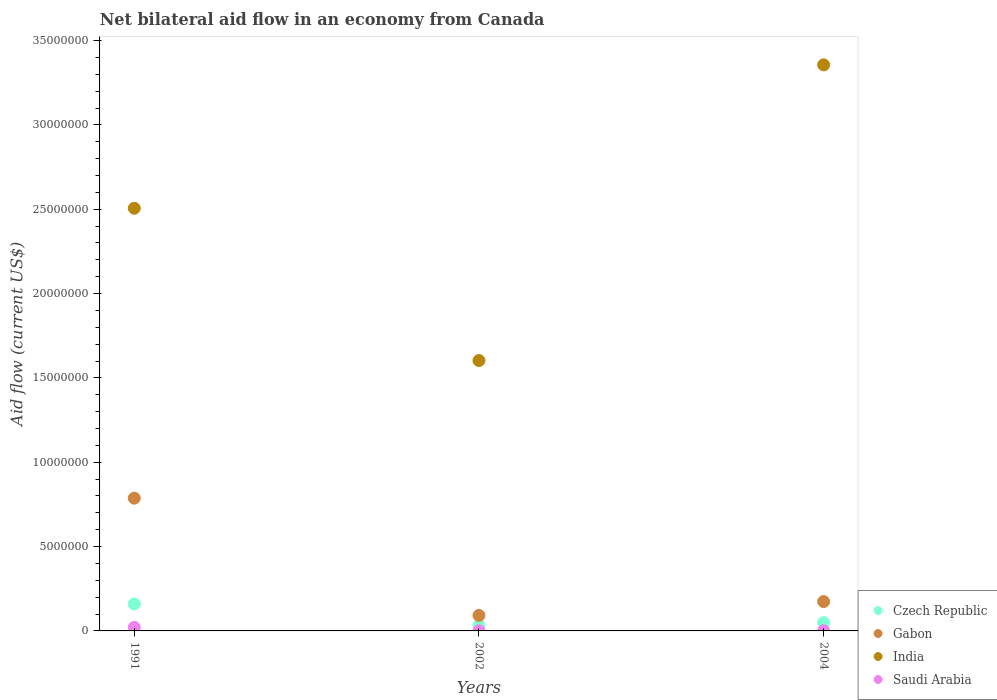Across all years, what is the maximum net bilateral aid flow in Gabon?
Make the answer very short. 7.87e+06. Across all years, what is the minimum net bilateral aid flow in Gabon?
Make the answer very short. 9.20e+05. In which year was the net bilateral aid flow in Czech Republic maximum?
Your answer should be very brief. 1991. In which year was the net bilateral aid flow in India minimum?
Offer a terse response. 2002. What is the difference between the net bilateral aid flow in Saudi Arabia in 2004 and the net bilateral aid flow in Czech Republic in 2002?
Provide a succinct answer. -3.20e+05. What is the average net bilateral aid flow in Czech Republic per year?
Your response must be concise. 8.07e+05. In the year 2004, what is the difference between the net bilateral aid flow in Saudi Arabia and net bilateral aid flow in Gabon?
Offer a terse response. -1.73e+06. In how many years, is the net bilateral aid flow in India greater than 7000000 US$?
Your answer should be compact. 3. What is the ratio of the net bilateral aid flow in India in 1991 to that in 2002?
Offer a very short reply. 1.56. Is the difference between the net bilateral aid flow in Saudi Arabia in 2002 and 2004 greater than the difference between the net bilateral aid flow in Gabon in 2002 and 2004?
Offer a very short reply. Yes. What is the difference between the highest and the second highest net bilateral aid flow in Gabon?
Offer a terse response. 6.13e+06. What is the difference between the highest and the lowest net bilateral aid flow in Czech Republic?
Make the answer very short. 1.27e+06. Is the sum of the net bilateral aid flow in Saudi Arabia in 2002 and 2004 greater than the maximum net bilateral aid flow in Gabon across all years?
Your response must be concise. No. Is it the case that in every year, the sum of the net bilateral aid flow in Czech Republic and net bilateral aid flow in Saudi Arabia  is greater than the sum of net bilateral aid flow in India and net bilateral aid flow in Gabon?
Your answer should be very brief. No. Is it the case that in every year, the sum of the net bilateral aid flow in India and net bilateral aid flow in Gabon  is greater than the net bilateral aid flow in Saudi Arabia?
Provide a short and direct response. Yes. How many dotlines are there?
Your answer should be compact. 4. Does the graph contain grids?
Provide a succinct answer. No. Where does the legend appear in the graph?
Ensure brevity in your answer.  Bottom right. How many legend labels are there?
Ensure brevity in your answer.  4. What is the title of the graph?
Keep it short and to the point. Net bilateral aid flow in an economy from Canada. What is the label or title of the X-axis?
Your response must be concise. Years. What is the label or title of the Y-axis?
Provide a succinct answer. Aid flow (current US$). What is the Aid flow (current US$) in Czech Republic in 1991?
Keep it short and to the point. 1.60e+06. What is the Aid flow (current US$) of Gabon in 1991?
Your answer should be compact. 7.87e+06. What is the Aid flow (current US$) of India in 1991?
Your response must be concise. 2.51e+07. What is the Aid flow (current US$) of Gabon in 2002?
Keep it short and to the point. 9.20e+05. What is the Aid flow (current US$) of India in 2002?
Provide a succinct answer. 1.60e+07. What is the Aid flow (current US$) of Gabon in 2004?
Offer a terse response. 1.74e+06. What is the Aid flow (current US$) in India in 2004?
Provide a succinct answer. 3.36e+07. What is the Aid flow (current US$) of Saudi Arabia in 2004?
Your answer should be compact. 10000. Across all years, what is the maximum Aid flow (current US$) of Czech Republic?
Your answer should be very brief. 1.60e+06. Across all years, what is the maximum Aid flow (current US$) in Gabon?
Keep it short and to the point. 7.87e+06. Across all years, what is the maximum Aid flow (current US$) in India?
Provide a short and direct response. 3.36e+07. Across all years, what is the minimum Aid flow (current US$) in Czech Republic?
Offer a terse response. 3.30e+05. Across all years, what is the minimum Aid flow (current US$) in Gabon?
Offer a very short reply. 9.20e+05. Across all years, what is the minimum Aid flow (current US$) of India?
Ensure brevity in your answer.  1.60e+07. What is the total Aid flow (current US$) in Czech Republic in the graph?
Offer a terse response. 2.42e+06. What is the total Aid flow (current US$) in Gabon in the graph?
Ensure brevity in your answer.  1.05e+07. What is the total Aid flow (current US$) of India in the graph?
Your response must be concise. 7.46e+07. What is the difference between the Aid flow (current US$) in Czech Republic in 1991 and that in 2002?
Your answer should be compact. 1.27e+06. What is the difference between the Aid flow (current US$) in Gabon in 1991 and that in 2002?
Keep it short and to the point. 6.95e+06. What is the difference between the Aid flow (current US$) in India in 1991 and that in 2002?
Give a very brief answer. 9.03e+06. What is the difference between the Aid flow (current US$) in Saudi Arabia in 1991 and that in 2002?
Your answer should be very brief. 2.00e+05. What is the difference between the Aid flow (current US$) in Czech Republic in 1991 and that in 2004?
Your response must be concise. 1.11e+06. What is the difference between the Aid flow (current US$) of Gabon in 1991 and that in 2004?
Your answer should be compact. 6.13e+06. What is the difference between the Aid flow (current US$) in India in 1991 and that in 2004?
Your answer should be very brief. -8.50e+06. What is the difference between the Aid flow (current US$) in Saudi Arabia in 1991 and that in 2004?
Make the answer very short. 2.00e+05. What is the difference between the Aid flow (current US$) in Czech Republic in 2002 and that in 2004?
Make the answer very short. -1.60e+05. What is the difference between the Aid flow (current US$) of Gabon in 2002 and that in 2004?
Your answer should be compact. -8.20e+05. What is the difference between the Aid flow (current US$) in India in 2002 and that in 2004?
Ensure brevity in your answer.  -1.75e+07. What is the difference between the Aid flow (current US$) of Czech Republic in 1991 and the Aid flow (current US$) of Gabon in 2002?
Ensure brevity in your answer.  6.80e+05. What is the difference between the Aid flow (current US$) of Czech Republic in 1991 and the Aid flow (current US$) of India in 2002?
Your response must be concise. -1.44e+07. What is the difference between the Aid flow (current US$) in Czech Republic in 1991 and the Aid flow (current US$) in Saudi Arabia in 2002?
Ensure brevity in your answer.  1.59e+06. What is the difference between the Aid flow (current US$) in Gabon in 1991 and the Aid flow (current US$) in India in 2002?
Keep it short and to the point. -8.16e+06. What is the difference between the Aid flow (current US$) in Gabon in 1991 and the Aid flow (current US$) in Saudi Arabia in 2002?
Provide a short and direct response. 7.86e+06. What is the difference between the Aid flow (current US$) in India in 1991 and the Aid flow (current US$) in Saudi Arabia in 2002?
Provide a succinct answer. 2.50e+07. What is the difference between the Aid flow (current US$) in Czech Republic in 1991 and the Aid flow (current US$) in India in 2004?
Offer a terse response. -3.20e+07. What is the difference between the Aid flow (current US$) in Czech Republic in 1991 and the Aid flow (current US$) in Saudi Arabia in 2004?
Your answer should be compact. 1.59e+06. What is the difference between the Aid flow (current US$) of Gabon in 1991 and the Aid flow (current US$) of India in 2004?
Offer a very short reply. -2.57e+07. What is the difference between the Aid flow (current US$) of Gabon in 1991 and the Aid flow (current US$) of Saudi Arabia in 2004?
Your response must be concise. 7.86e+06. What is the difference between the Aid flow (current US$) in India in 1991 and the Aid flow (current US$) in Saudi Arabia in 2004?
Your response must be concise. 2.50e+07. What is the difference between the Aid flow (current US$) of Czech Republic in 2002 and the Aid flow (current US$) of Gabon in 2004?
Keep it short and to the point. -1.41e+06. What is the difference between the Aid flow (current US$) in Czech Republic in 2002 and the Aid flow (current US$) in India in 2004?
Provide a succinct answer. -3.32e+07. What is the difference between the Aid flow (current US$) in Czech Republic in 2002 and the Aid flow (current US$) in Saudi Arabia in 2004?
Offer a terse response. 3.20e+05. What is the difference between the Aid flow (current US$) in Gabon in 2002 and the Aid flow (current US$) in India in 2004?
Your answer should be compact. -3.26e+07. What is the difference between the Aid flow (current US$) in Gabon in 2002 and the Aid flow (current US$) in Saudi Arabia in 2004?
Provide a succinct answer. 9.10e+05. What is the difference between the Aid flow (current US$) in India in 2002 and the Aid flow (current US$) in Saudi Arabia in 2004?
Make the answer very short. 1.60e+07. What is the average Aid flow (current US$) in Czech Republic per year?
Ensure brevity in your answer.  8.07e+05. What is the average Aid flow (current US$) in Gabon per year?
Your response must be concise. 3.51e+06. What is the average Aid flow (current US$) in India per year?
Provide a short and direct response. 2.49e+07. What is the average Aid flow (current US$) of Saudi Arabia per year?
Ensure brevity in your answer.  7.67e+04. In the year 1991, what is the difference between the Aid flow (current US$) in Czech Republic and Aid flow (current US$) in Gabon?
Give a very brief answer. -6.27e+06. In the year 1991, what is the difference between the Aid flow (current US$) of Czech Republic and Aid flow (current US$) of India?
Give a very brief answer. -2.35e+07. In the year 1991, what is the difference between the Aid flow (current US$) of Czech Republic and Aid flow (current US$) of Saudi Arabia?
Offer a terse response. 1.39e+06. In the year 1991, what is the difference between the Aid flow (current US$) in Gabon and Aid flow (current US$) in India?
Provide a short and direct response. -1.72e+07. In the year 1991, what is the difference between the Aid flow (current US$) in Gabon and Aid flow (current US$) in Saudi Arabia?
Your response must be concise. 7.66e+06. In the year 1991, what is the difference between the Aid flow (current US$) in India and Aid flow (current US$) in Saudi Arabia?
Ensure brevity in your answer.  2.48e+07. In the year 2002, what is the difference between the Aid flow (current US$) in Czech Republic and Aid flow (current US$) in Gabon?
Ensure brevity in your answer.  -5.90e+05. In the year 2002, what is the difference between the Aid flow (current US$) in Czech Republic and Aid flow (current US$) in India?
Make the answer very short. -1.57e+07. In the year 2002, what is the difference between the Aid flow (current US$) of Czech Republic and Aid flow (current US$) of Saudi Arabia?
Provide a succinct answer. 3.20e+05. In the year 2002, what is the difference between the Aid flow (current US$) in Gabon and Aid flow (current US$) in India?
Your answer should be compact. -1.51e+07. In the year 2002, what is the difference between the Aid flow (current US$) in Gabon and Aid flow (current US$) in Saudi Arabia?
Ensure brevity in your answer.  9.10e+05. In the year 2002, what is the difference between the Aid flow (current US$) of India and Aid flow (current US$) of Saudi Arabia?
Provide a succinct answer. 1.60e+07. In the year 2004, what is the difference between the Aid flow (current US$) of Czech Republic and Aid flow (current US$) of Gabon?
Your response must be concise. -1.25e+06. In the year 2004, what is the difference between the Aid flow (current US$) of Czech Republic and Aid flow (current US$) of India?
Provide a succinct answer. -3.31e+07. In the year 2004, what is the difference between the Aid flow (current US$) of Czech Republic and Aid flow (current US$) of Saudi Arabia?
Provide a succinct answer. 4.80e+05. In the year 2004, what is the difference between the Aid flow (current US$) in Gabon and Aid flow (current US$) in India?
Your answer should be very brief. -3.18e+07. In the year 2004, what is the difference between the Aid flow (current US$) of Gabon and Aid flow (current US$) of Saudi Arabia?
Keep it short and to the point. 1.73e+06. In the year 2004, what is the difference between the Aid flow (current US$) of India and Aid flow (current US$) of Saudi Arabia?
Offer a terse response. 3.36e+07. What is the ratio of the Aid flow (current US$) of Czech Republic in 1991 to that in 2002?
Your answer should be very brief. 4.85. What is the ratio of the Aid flow (current US$) in Gabon in 1991 to that in 2002?
Provide a succinct answer. 8.55. What is the ratio of the Aid flow (current US$) in India in 1991 to that in 2002?
Your answer should be very brief. 1.56. What is the ratio of the Aid flow (current US$) of Saudi Arabia in 1991 to that in 2002?
Keep it short and to the point. 21. What is the ratio of the Aid flow (current US$) in Czech Republic in 1991 to that in 2004?
Your answer should be very brief. 3.27. What is the ratio of the Aid flow (current US$) in Gabon in 1991 to that in 2004?
Provide a short and direct response. 4.52. What is the ratio of the Aid flow (current US$) of India in 1991 to that in 2004?
Your response must be concise. 0.75. What is the ratio of the Aid flow (current US$) of Saudi Arabia in 1991 to that in 2004?
Offer a terse response. 21. What is the ratio of the Aid flow (current US$) of Czech Republic in 2002 to that in 2004?
Your answer should be compact. 0.67. What is the ratio of the Aid flow (current US$) in Gabon in 2002 to that in 2004?
Ensure brevity in your answer.  0.53. What is the ratio of the Aid flow (current US$) of India in 2002 to that in 2004?
Offer a very short reply. 0.48. What is the ratio of the Aid flow (current US$) of Saudi Arabia in 2002 to that in 2004?
Keep it short and to the point. 1. What is the difference between the highest and the second highest Aid flow (current US$) of Czech Republic?
Keep it short and to the point. 1.11e+06. What is the difference between the highest and the second highest Aid flow (current US$) in Gabon?
Offer a very short reply. 6.13e+06. What is the difference between the highest and the second highest Aid flow (current US$) in India?
Offer a terse response. 8.50e+06. What is the difference between the highest and the lowest Aid flow (current US$) of Czech Republic?
Your answer should be compact. 1.27e+06. What is the difference between the highest and the lowest Aid flow (current US$) of Gabon?
Provide a succinct answer. 6.95e+06. What is the difference between the highest and the lowest Aid flow (current US$) in India?
Provide a short and direct response. 1.75e+07. 